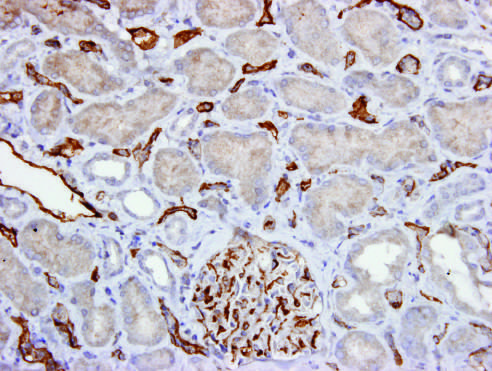does the acute t cell-mediated rejection stain show c4d deposition in peritubular capillaries and a glomerulus?
Answer the question using a single word or phrase. No 